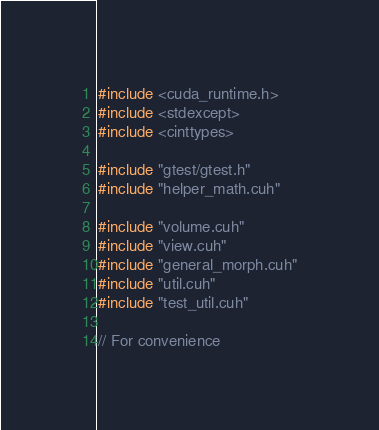<code> <loc_0><loc_0><loc_500><loc_500><_Cuda_>#include <cuda_runtime.h>
#include <stdexcept>
#include <cinttypes>

#include "gtest/gtest.h"
#include "helper_math.cuh"

#include "volume.cuh"
#include "view.cuh"
#include "general_morph.cuh"
#include "util.cuh"
#include "test_util.cuh"

// For convenience</code> 